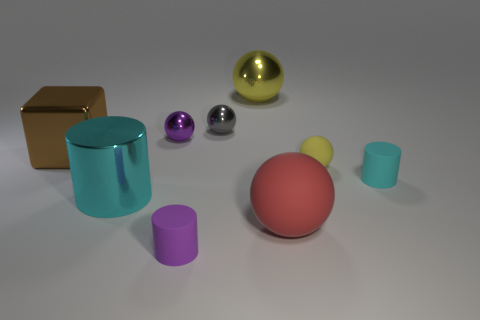Is the small cyan object the same shape as the brown object?
Give a very brief answer. No. What number of things are cyan things that are to the right of the red object or balls behind the big brown cube?
Make the answer very short. 4. What number of objects are either large cylinders or purple objects?
Provide a succinct answer. 3. What number of things are to the left of the matte cylinder in front of the cyan metal cylinder?
Ensure brevity in your answer.  3. How many other objects are the same size as the purple cylinder?
Offer a terse response. 4. There is another cylinder that is the same color as the large metallic cylinder; what is its size?
Make the answer very short. Small. There is a cyan object on the right side of the large rubber object; is it the same shape as the brown metal object?
Give a very brief answer. No. There is a tiny ball in front of the block; what is it made of?
Your answer should be very brief. Rubber. There is a thing that is the same color as the large cylinder; what is its shape?
Your response must be concise. Cylinder. Is there a blue block that has the same material as the tiny yellow object?
Ensure brevity in your answer.  No. 